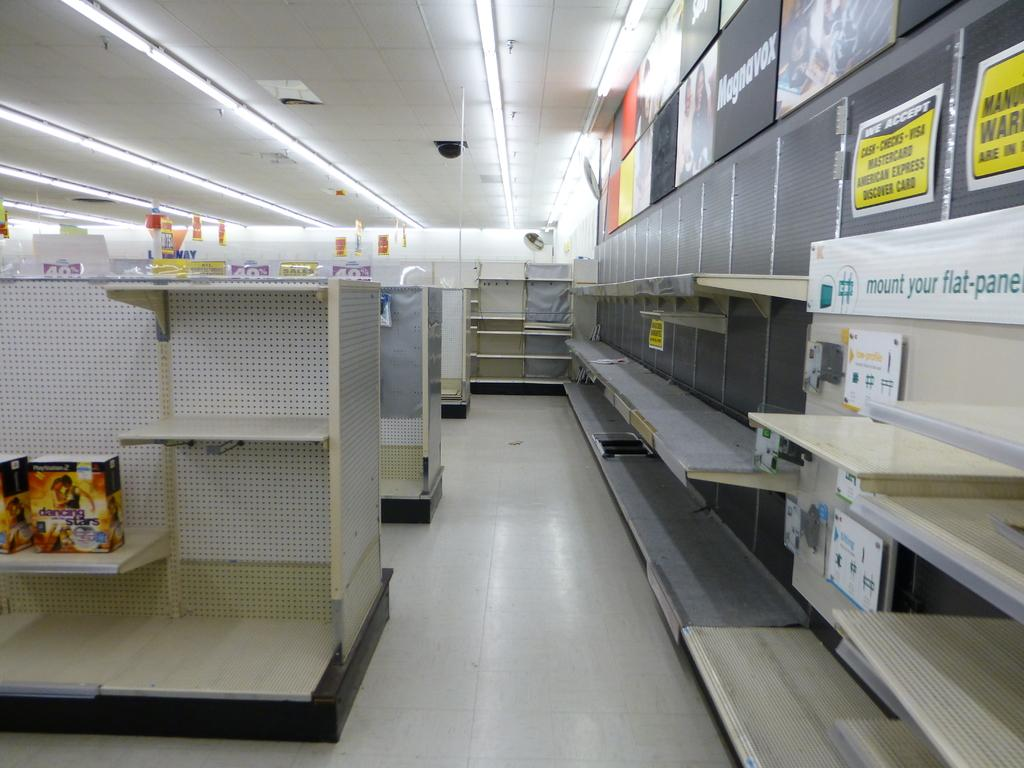Provide a one-sentence caption for the provided image. Empty electronics section with a sign that says "mount your flat-panel". 